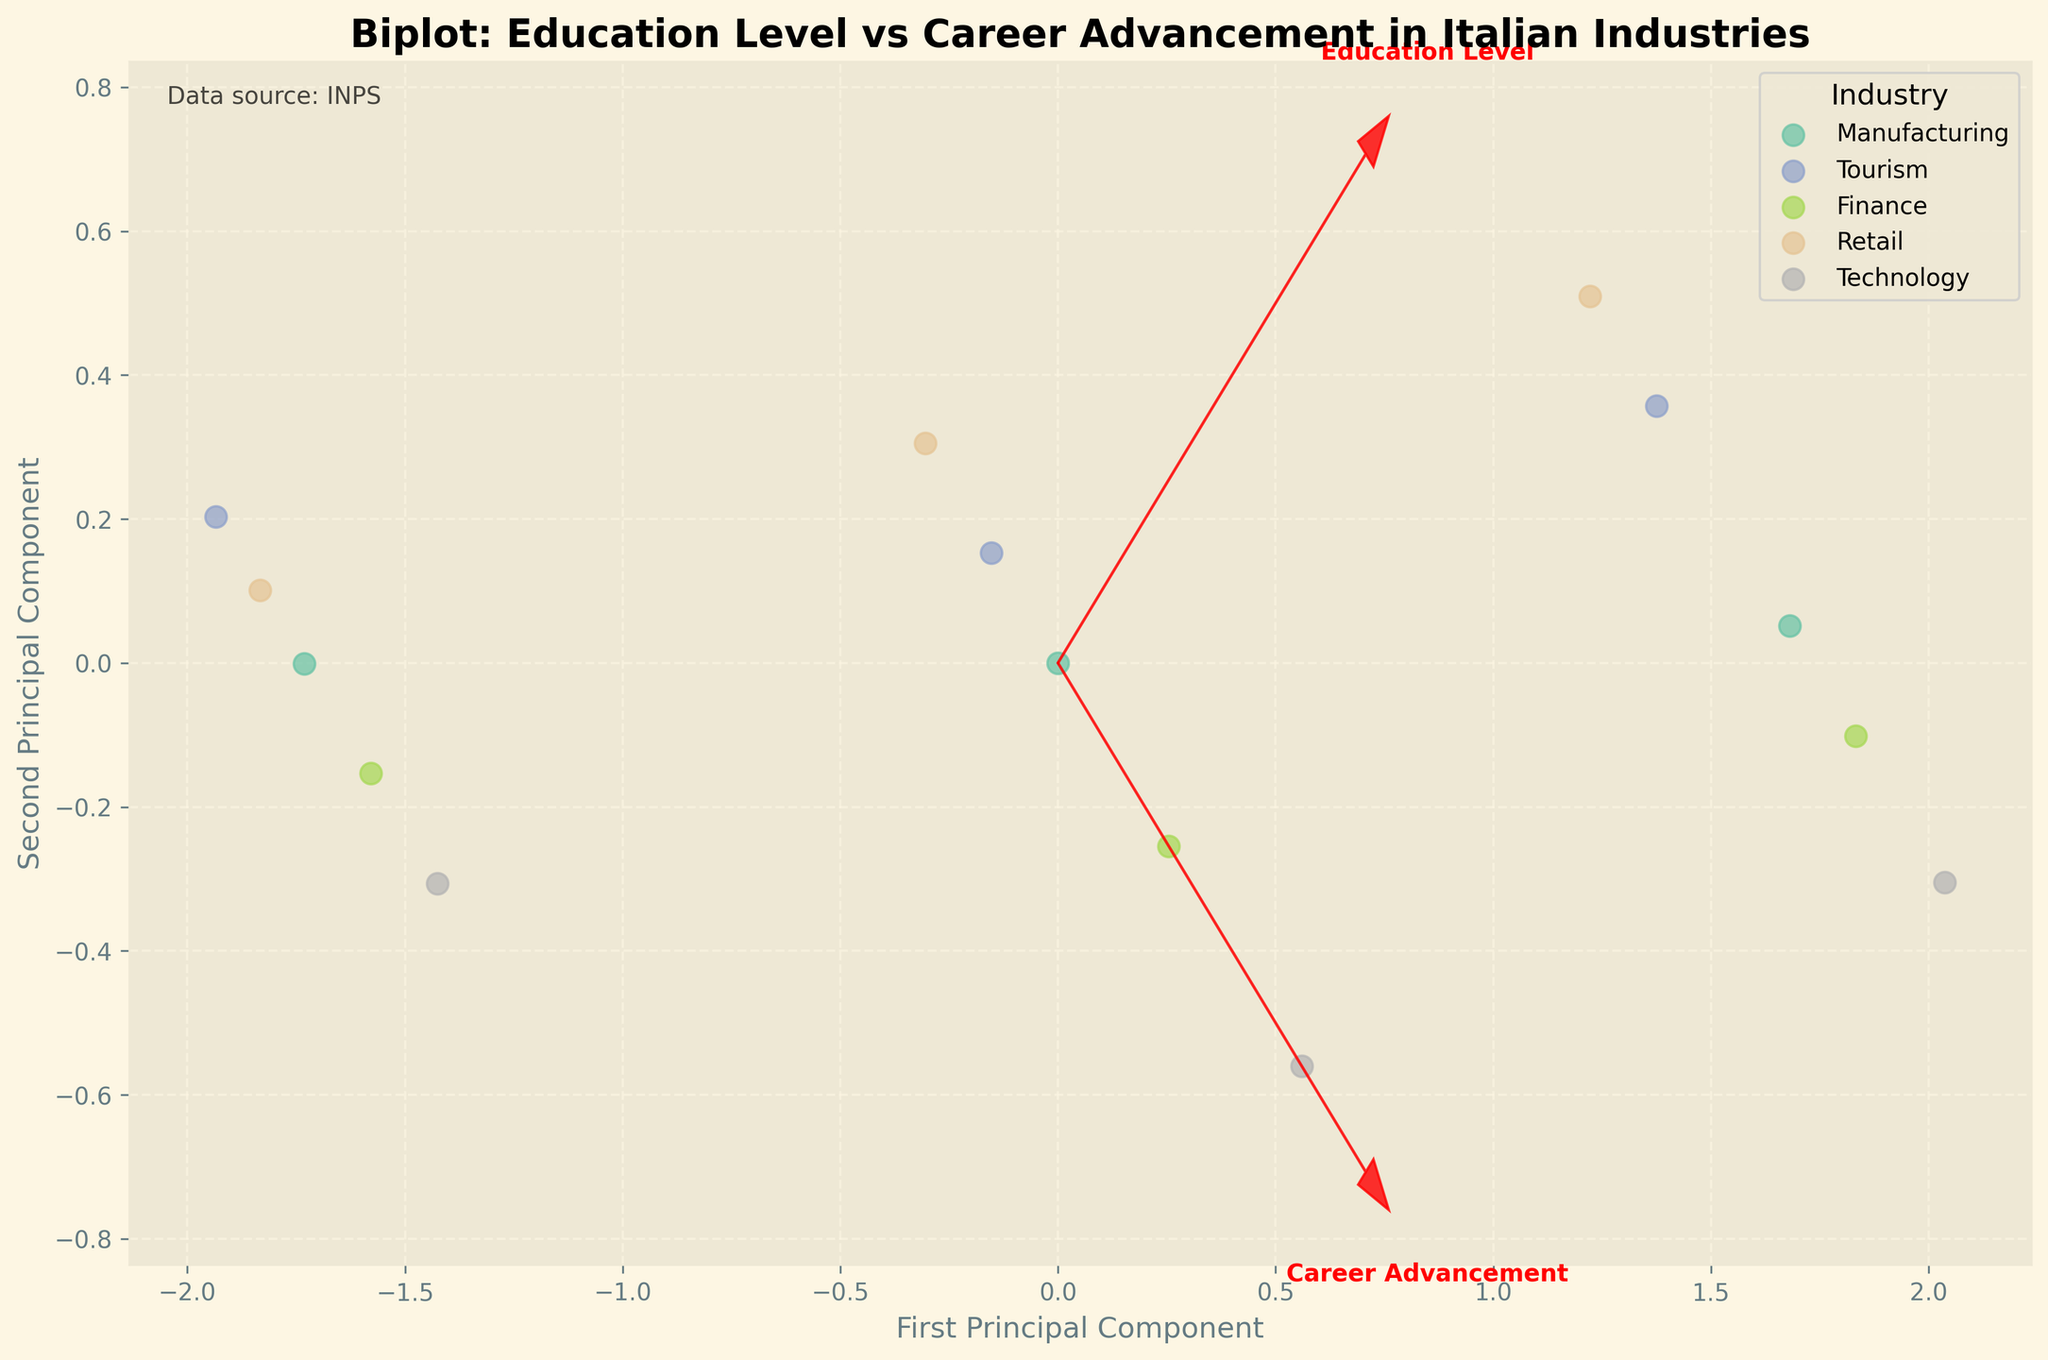How many different industries are represented in the biplot? By observing the legend of the biplot, we can count the number of unique colors and corresponding industry labels that are displayed.
Answer: 5 Which industry has the highest career advancement score? The industry with the data points located farthest along the arrow representing career advancement score shows the highest value. By checking the scatter points along this direction, we identify that the Technology industry has the highest values.
Answer: Technology What is the main relationship between education level and career advancement score in the plot? The arrows representing the variables show their directions and relative length. In this biplot, both Education Level and Career Advancement arrows point in similar directions, indicating a positive correlation. Higher education levels are associated with higher career advancement scores.
Answer: Positive correlation Among the industries displayed, which one has the lowest career advancement score for a high school diploma? By locating the data points labeled "High School Diploma" along the career advancement direction, the lowest point among them belongs to the Tourism industry.
Answer: Tourism Which industry shows the greatest variation in career advancement scores across different education levels? By examining the spread of data points within each industry cluster in the scatter plot, we can see that the Technology industry shows the greatest variation from high school diploma to master's degree.
Answer: Technology Are there any industries where a bachelor's degree provides similar career advancement scores as a master's degree in other industries? By comparing the data clusters for bachelor's degrees to master's degrees across industries, we can observe that a bachelor's degree in Technology or Finance offers similar scores to a master's degree in Retail.
Answer: Yes Between Manufacturing and Retail industries, which one shows higher career advancement scores for bachelor's degree holders? By comparing the data points labeled "Bachelor's Degree" within the Manufacturing and Retail clusters, we find that the Manufacturing industry data points are positioned higher along the career advancement direction.
Answer: Manufacturing What is the position of the "Education Level" vector relative to the first principal component? By observing the direction of the "Education Level" arrow, we notice that it is aligned mostly along the first principal component axis, indicating that it is more influential in this component.
Answer: Aligned with the first principal component Does the inclusion of Education Level alone explain more variance in career advancement scores compared to industry differences? Since the vector for "Education Level" is notably long and points in the same direction as "Career Advancement Score," it implies that Education Level explains a significant portion of the variance. Industry differences add additional but less variance.
Answer: Yes How can we interpret the cluster of points for the Finance industry in terms of education level and career advancement? The Finance industry cluster shows a clear upward trend from high school diploma to master's degree, indicating that higher education levels correspond to better career advancement opportunities within this industry.
Answer: Clear upward trend 